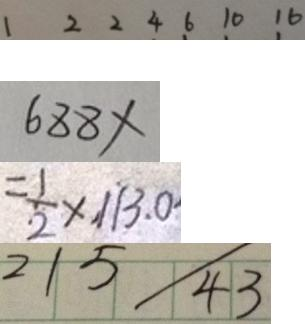Convert formula to latex. <formula><loc_0><loc_0><loc_500><loc_500>1 2 2 4 6 1 0 1 6 
 6 8 8 \times 
 = \frac { 1 } { 2 } \times 1 1 3 . 0 
 2 1 5 / 4 3</formula> 